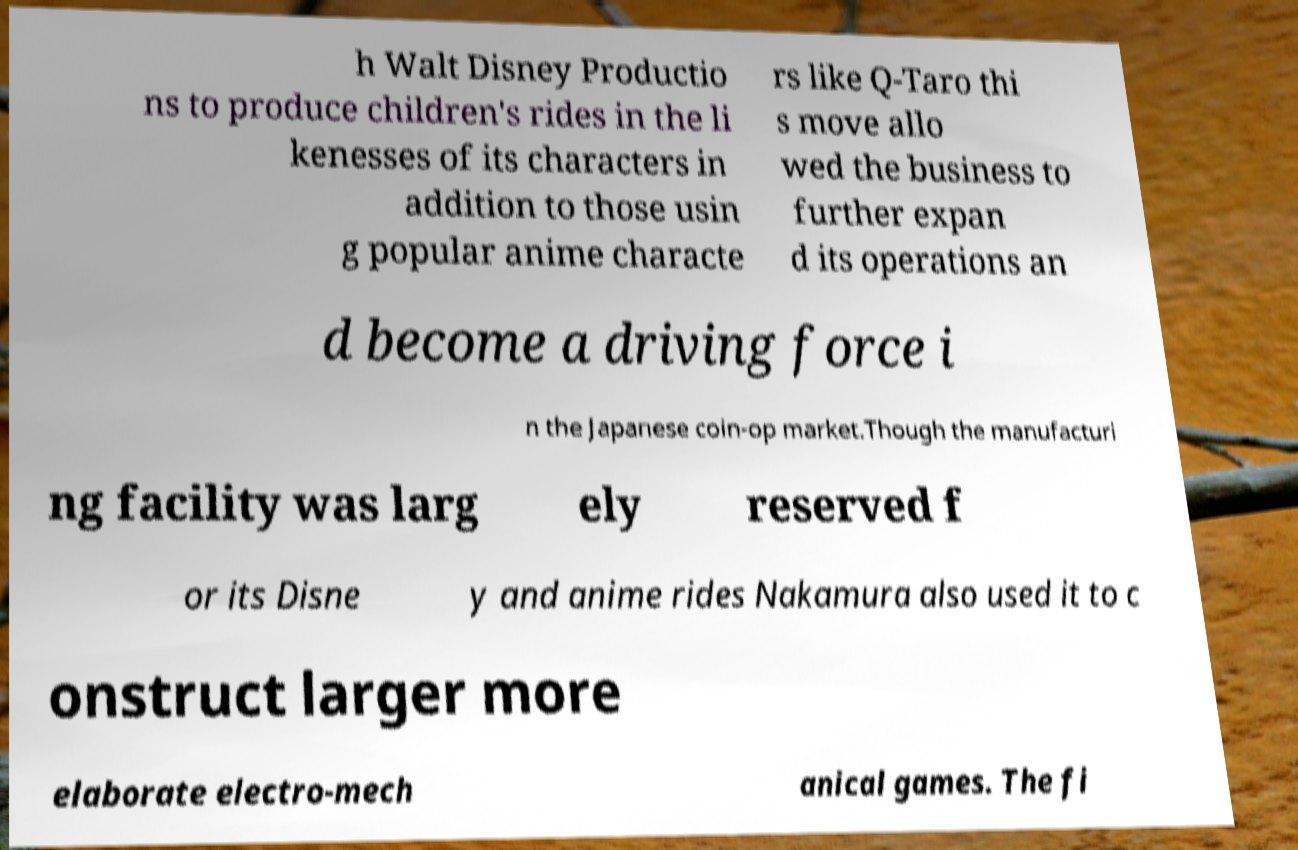For documentation purposes, I need the text within this image transcribed. Could you provide that? h Walt Disney Productio ns to produce children's rides in the li kenesses of its characters in addition to those usin g popular anime characte rs like Q-Taro thi s move allo wed the business to further expan d its operations an d become a driving force i n the Japanese coin-op market.Though the manufacturi ng facility was larg ely reserved f or its Disne y and anime rides Nakamura also used it to c onstruct larger more elaborate electro-mech anical games. The fi 